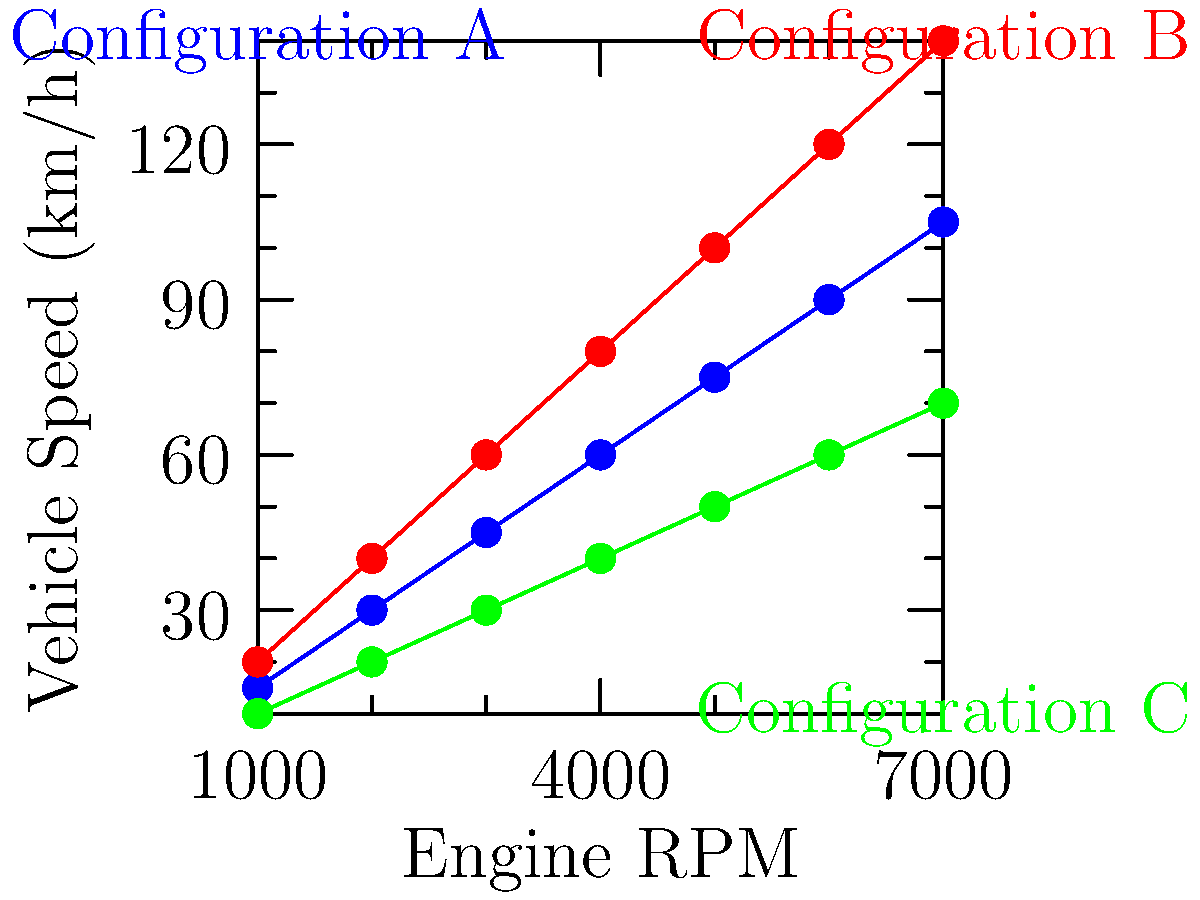Based on the graph showing the relationship between engine RPM and vehicle speed for three different transmission configurations, which configuration would be most suitable for a high-speed racing event on a track with long straightaways? To determine the most suitable configuration for a high-speed racing event with long straightaways, we need to analyze the graph and consider the following points:

1. The graph shows three different transmission configurations (A, B, and C) and their respective relationships between engine RPM and vehicle speed.

2. For high-speed racing, we want a configuration that allows for the highest top speed at the maximum engine RPM.

3. Examining the graph at 7000 RPM (the highest point on the x-axis):
   - Configuration A (blue) reaches approximately 105 km/h
   - Configuration B (red) reaches approximately 140 km/h
   - Configuration C (green) reaches approximately 70 km/h

4. Configuration B clearly provides the highest top speed at maximum RPM.

5. Additionally, Configuration B has the steepest slope, indicating that it provides the greatest increase in speed per increase in RPM. This means it will accelerate more quickly on straightaways.

6. While Configuration C might be useful for better control in corners due to its lower speeds, and Configuration A offers a balance between B and C, neither is ideal for maximizing speed on long straightaways.

Given these observations, Configuration B would be the most suitable for a high-speed racing event on a track with long straightaways, as it offers the highest top speed and the best acceleration characteristics.
Answer: Configuration B 